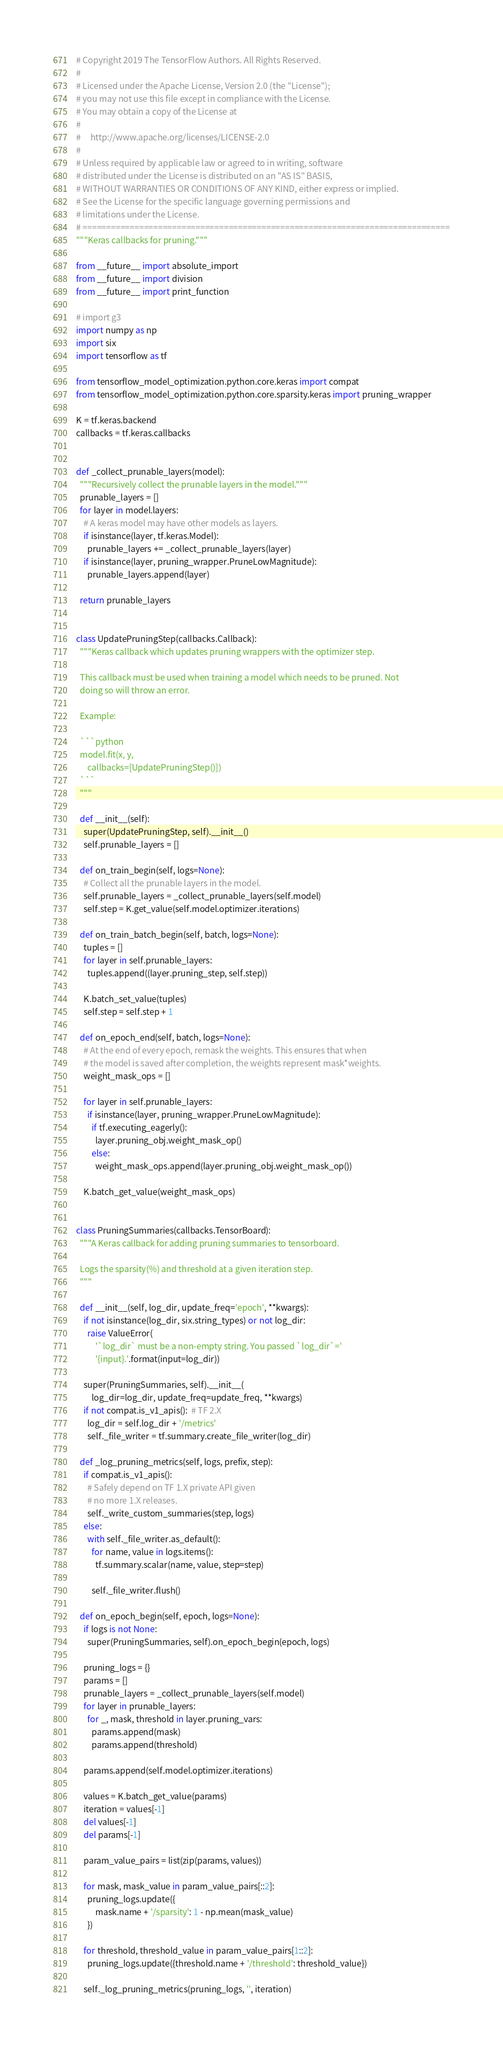<code> <loc_0><loc_0><loc_500><loc_500><_Python_># Copyright 2019 The TensorFlow Authors. All Rights Reserved.
#
# Licensed under the Apache License, Version 2.0 (the "License");
# you may not use this file except in compliance with the License.
# You may obtain a copy of the License at
#
#     http://www.apache.org/licenses/LICENSE-2.0
#
# Unless required by applicable law or agreed to in writing, software
# distributed under the License is distributed on an "AS IS" BASIS,
# WITHOUT WARRANTIES OR CONDITIONS OF ANY KIND, either express or implied.
# See the License for the specific language governing permissions and
# limitations under the License.
# ==============================================================================
"""Keras callbacks for pruning."""

from __future__ import absolute_import
from __future__ import division
from __future__ import print_function

# import g3
import numpy as np
import six
import tensorflow as tf

from tensorflow_model_optimization.python.core.keras import compat
from tensorflow_model_optimization.python.core.sparsity.keras import pruning_wrapper

K = tf.keras.backend
callbacks = tf.keras.callbacks


def _collect_prunable_layers(model):
  """Recursively collect the prunable layers in the model."""
  prunable_layers = []
  for layer in model.layers:
    # A keras model may have other models as layers.
    if isinstance(layer, tf.keras.Model):
      prunable_layers += _collect_prunable_layers(layer)
    if isinstance(layer, pruning_wrapper.PruneLowMagnitude):
      prunable_layers.append(layer)

  return prunable_layers


class UpdatePruningStep(callbacks.Callback):
  """Keras callback which updates pruning wrappers with the optimizer step.

  This callback must be used when training a model which needs to be pruned. Not
  doing so will throw an error.

  Example:

  ```python
  model.fit(x, y,
      callbacks=[UpdatePruningStep()])
  ```
  """

  def __init__(self):
    super(UpdatePruningStep, self).__init__()
    self.prunable_layers = []

  def on_train_begin(self, logs=None):
    # Collect all the prunable layers in the model.
    self.prunable_layers = _collect_prunable_layers(self.model)
    self.step = K.get_value(self.model.optimizer.iterations)

  def on_train_batch_begin(self, batch, logs=None):
    tuples = []
    for layer in self.prunable_layers:
      tuples.append((layer.pruning_step, self.step))

    K.batch_set_value(tuples)
    self.step = self.step + 1

  def on_epoch_end(self, batch, logs=None):
    # At the end of every epoch, remask the weights. This ensures that when
    # the model is saved after completion, the weights represent mask*weights.
    weight_mask_ops = []

    for layer in self.prunable_layers:
      if isinstance(layer, pruning_wrapper.PruneLowMagnitude):
        if tf.executing_eagerly():
          layer.pruning_obj.weight_mask_op()
        else:
          weight_mask_ops.append(layer.pruning_obj.weight_mask_op())

    K.batch_get_value(weight_mask_ops)


class PruningSummaries(callbacks.TensorBoard):
  """A Keras callback for adding pruning summaries to tensorboard.

  Logs the sparsity(%) and threshold at a given iteration step.
  """

  def __init__(self, log_dir, update_freq='epoch', **kwargs):
    if not isinstance(log_dir, six.string_types) or not log_dir:
      raise ValueError(
          '`log_dir` must be a non-empty string. You passed `log_dir`='
          '{input}.'.format(input=log_dir))

    super(PruningSummaries, self).__init__(
        log_dir=log_dir, update_freq=update_freq, **kwargs)
    if not compat.is_v1_apis():  # TF 2.X
      log_dir = self.log_dir + '/metrics'
      self._file_writer = tf.summary.create_file_writer(log_dir)

  def _log_pruning_metrics(self, logs, prefix, step):
    if compat.is_v1_apis():
      # Safely depend on TF 1.X private API given
      # no more 1.X releases.
      self._write_custom_summaries(step, logs)
    else:
      with self._file_writer.as_default():
        for name, value in logs.items():
          tf.summary.scalar(name, value, step=step)

        self._file_writer.flush()

  def on_epoch_begin(self, epoch, logs=None):
    if logs is not None:
      super(PruningSummaries, self).on_epoch_begin(epoch, logs)

    pruning_logs = {}
    params = []
    prunable_layers = _collect_prunable_layers(self.model)
    for layer in prunable_layers:
      for _, mask, threshold in layer.pruning_vars:
        params.append(mask)
        params.append(threshold)

    params.append(self.model.optimizer.iterations)

    values = K.batch_get_value(params)
    iteration = values[-1]
    del values[-1]
    del params[-1]

    param_value_pairs = list(zip(params, values))

    for mask, mask_value in param_value_pairs[::2]:
      pruning_logs.update({
          mask.name + '/sparsity': 1 - np.mean(mask_value)
      })

    for threshold, threshold_value in param_value_pairs[1::2]:
      pruning_logs.update({threshold.name + '/threshold': threshold_value})

    self._log_pruning_metrics(pruning_logs, '', iteration)
</code> 